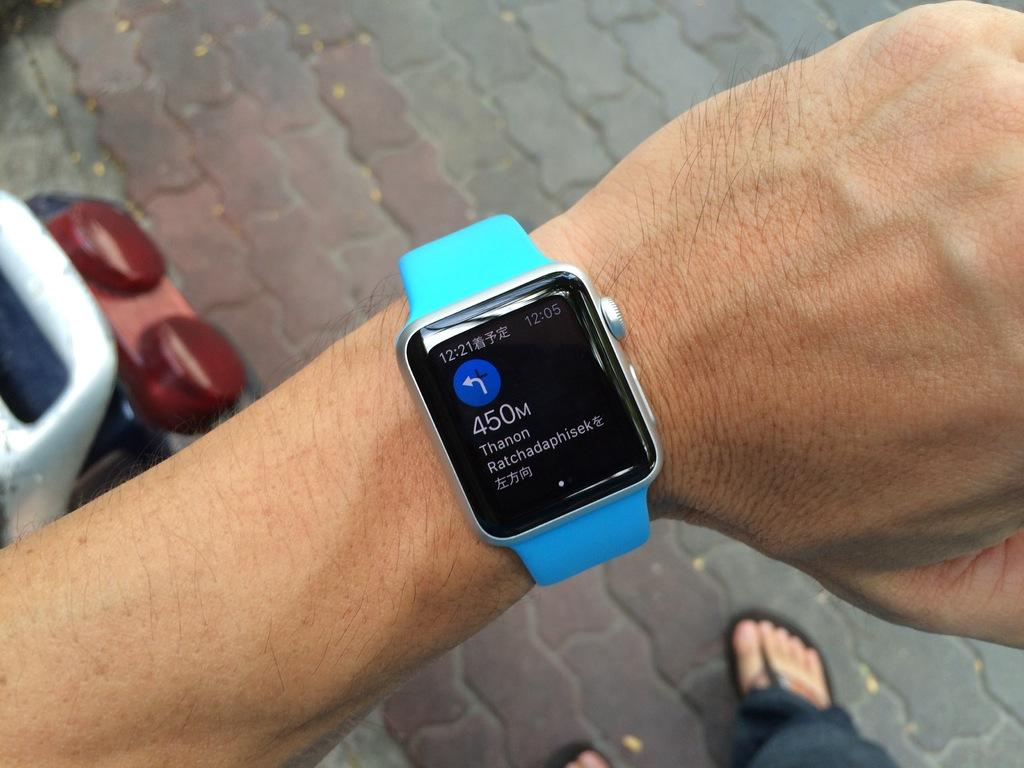<image>
Offer a succinct explanation of the picture presented. an apple watch on someones hand that says '450m' on it 